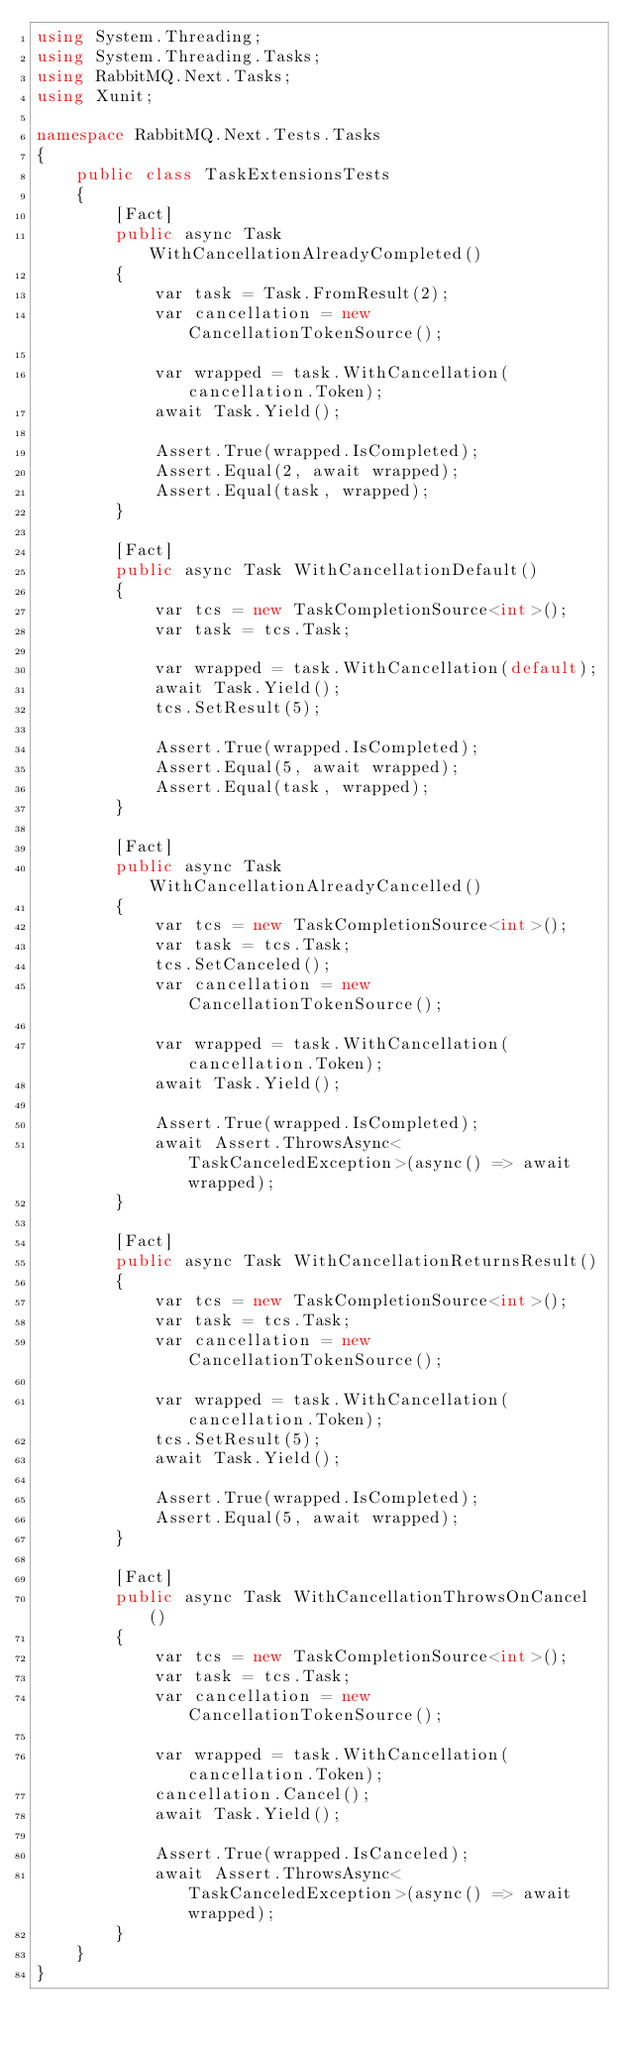<code> <loc_0><loc_0><loc_500><loc_500><_C#_>using System.Threading;
using System.Threading.Tasks;
using RabbitMQ.Next.Tasks;
using Xunit;

namespace RabbitMQ.Next.Tests.Tasks
{
    public class TaskExtensionsTests
    {
        [Fact]
        public async Task WithCancellationAlreadyCompleted()
        {
            var task = Task.FromResult(2);
            var cancellation = new CancellationTokenSource();

            var wrapped = task.WithCancellation(cancellation.Token);
            await Task.Yield();

            Assert.True(wrapped.IsCompleted);
            Assert.Equal(2, await wrapped);
            Assert.Equal(task, wrapped);
        }

        [Fact]
        public async Task WithCancellationDefault()
        {
            var tcs = new TaskCompletionSource<int>();
            var task = tcs.Task;

            var wrapped = task.WithCancellation(default);
            await Task.Yield();
            tcs.SetResult(5);

            Assert.True(wrapped.IsCompleted);
            Assert.Equal(5, await wrapped);
            Assert.Equal(task, wrapped);
        }

        [Fact]
        public async Task WithCancellationAlreadyCancelled()
        {
            var tcs = new TaskCompletionSource<int>();
            var task = tcs.Task;
            tcs.SetCanceled();
            var cancellation = new CancellationTokenSource();

            var wrapped = task.WithCancellation(cancellation.Token);
            await Task.Yield();

            Assert.True(wrapped.IsCompleted);
            await Assert.ThrowsAsync<TaskCanceledException>(async() => await wrapped);
        }

        [Fact]
        public async Task WithCancellationReturnsResult()
        {
            var tcs = new TaskCompletionSource<int>();
            var task = tcs.Task;
            var cancellation = new CancellationTokenSource();

            var wrapped = task.WithCancellation(cancellation.Token);
            tcs.SetResult(5);
            await Task.Yield();

            Assert.True(wrapped.IsCompleted);
            Assert.Equal(5, await wrapped);
        }

        [Fact]
        public async Task WithCancellationThrowsOnCancel()
        {
            var tcs = new TaskCompletionSource<int>();
            var task = tcs.Task;
            var cancellation = new CancellationTokenSource();

            var wrapped = task.WithCancellation(cancellation.Token);
            cancellation.Cancel();
            await Task.Yield();

            Assert.True(wrapped.IsCanceled);
            await Assert.ThrowsAsync<TaskCanceledException>(async() => await wrapped);
        }
    }
}</code> 